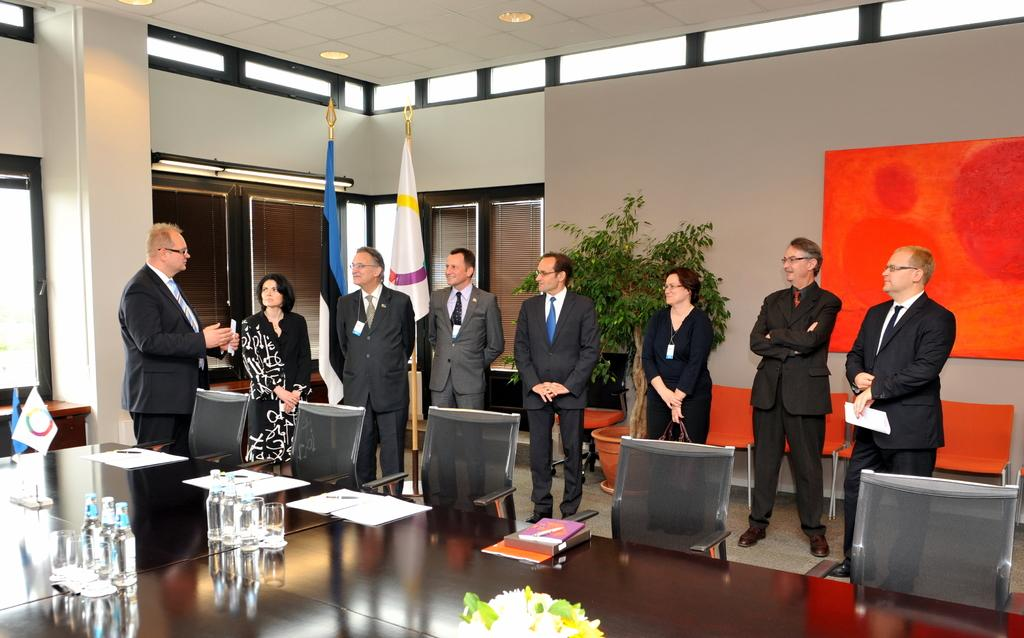What objects are on the table in the image? There are glasses, books, flowers, and bottles on the table in the image. What type of seating is present in the image? There are chairs in the image. What can be seen in the background of the image? There are flags and windows in the background. Are there any people present in the image? Yes, people are standing in the image. Can you tell me how many tigers are playing with the books in the image? There are no tigers present in the image, and therefore no such activity can be observed. 